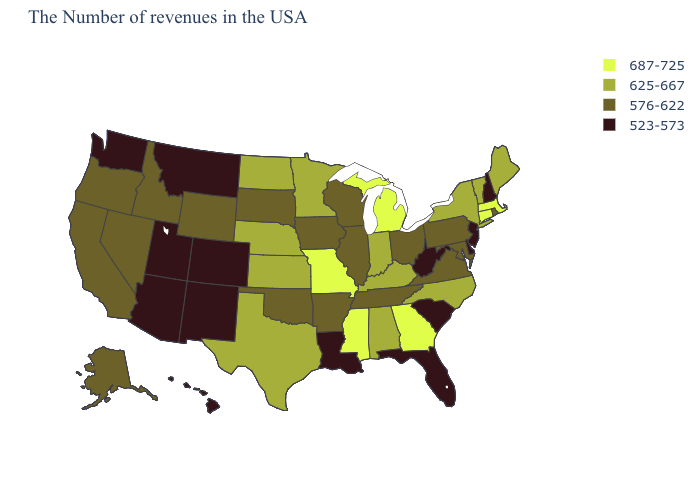What is the value of Wyoming?
Concise answer only. 576-622. Does Indiana have the lowest value in the MidWest?
Keep it brief. No. What is the value of California?
Write a very short answer. 576-622. Does Michigan have the highest value in the USA?
Concise answer only. Yes. Name the states that have a value in the range 576-622?
Keep it brief. Rhode Island, Maryland, Pennsylvania, Virginia, Ohio, Tennessee, Wisconsin, Illinois, Arkansas, Iowa, Oklahoma, South Dakota, Wyoming, Idaho, Nevada, California, Oregon, Alaska. What is the value of Minnesota?
Short answer required. 625-667. Does Delaware have the highest value in the South?
Quick response, please. No. What is the value of Vermont?
Be succinct. 625-667. Among the states that border Idaho , does Montana have the highest value?
Answer briefly. No. Name the states that have a value in the range 625-667?
Short answer required. Maine, Vermont, New York, North Carolina, Kentucky, Indiana, Alabama, Minnesota, Kansas, Nebraska, Texas, North Dakota. What is the highest value in the USA?
Be succinct. 687-725. What is the value of Maine?
Be succinct. 625-667. Is the legend a continuous bar?
Keep it brief. No. Among the states that border South Dakota , does Montana have the lowest value?
Keep it brief. Yes. What is the highest value in states that border New Mexico?
Be succinct. 625-667. 